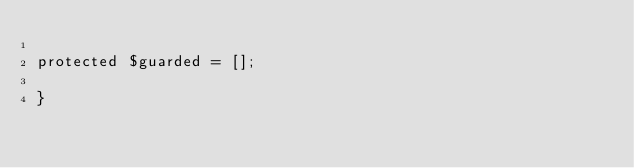Convert code to text. <code><loc_0><loc_0><loc_500><loc_500><_PHP_>
protected $guarded = [];

}
</code> 